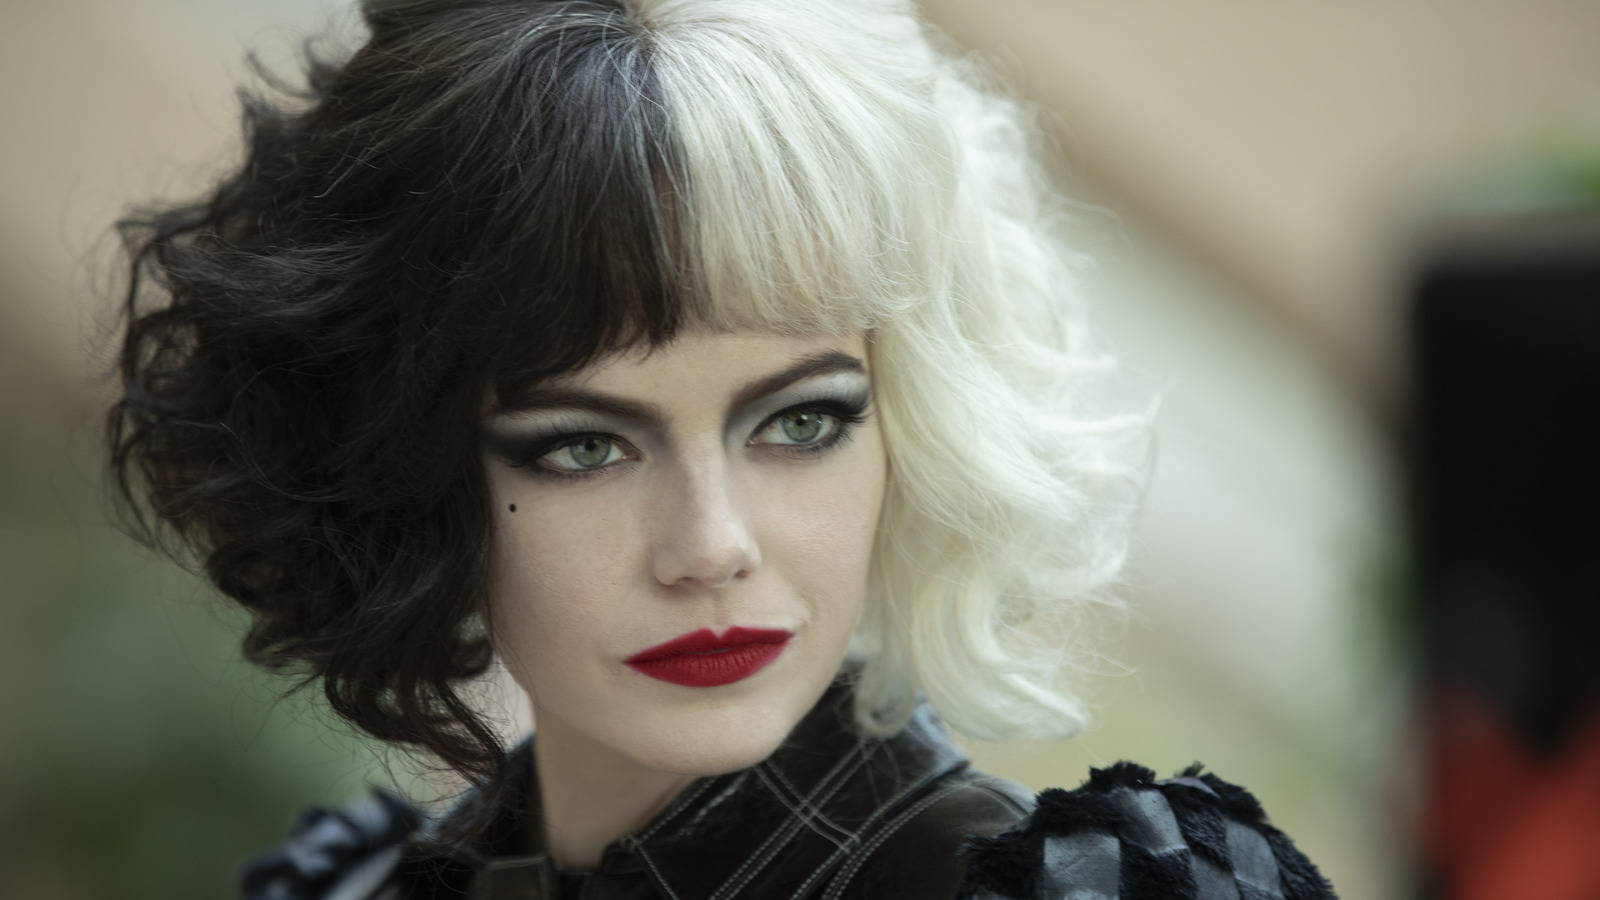What might the choice of a black and white color theme in Cruella de Vil's attire signify about her character? The black and white color scheme in Cruella de Vil's attire is deeply symbolic, representing the dual nature of her character. Traditionally, black can suggest sophistication but also villainy, while white might symbolize innocence but also coldness. The stark contrast between these colors underscores Cruella's complex persona—someone who is both elegant and edgy, with a morally ambiguous alignment that often veers into the realm of the villainous. 